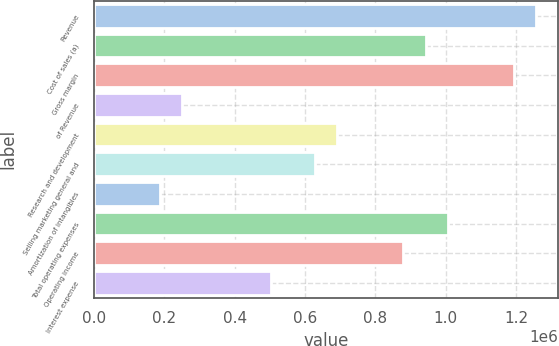Convert chart to OTSL. <chart><loc_0><loc_0><loc_500><loc_500><bar_chart><fcel>Revenue<fcel>Cost of sales (a)<fcel>Gross margin<fcel>of Revenue<fcel>Research and development<fcel>Selling marketing general and<fcel>Amortization of intangibles<fcel>Total operating expenses<fcel>Operating income<fcel>Interest expense<nl><fcel>1.25648e+06<fcel>942357<fcel>1.19365e+06<fcel>251295<fcel>691062<fcel>628238<fcel>188472<fcel>1.00518e+06<fcel>879533<fcel>502590<nl></chart> 